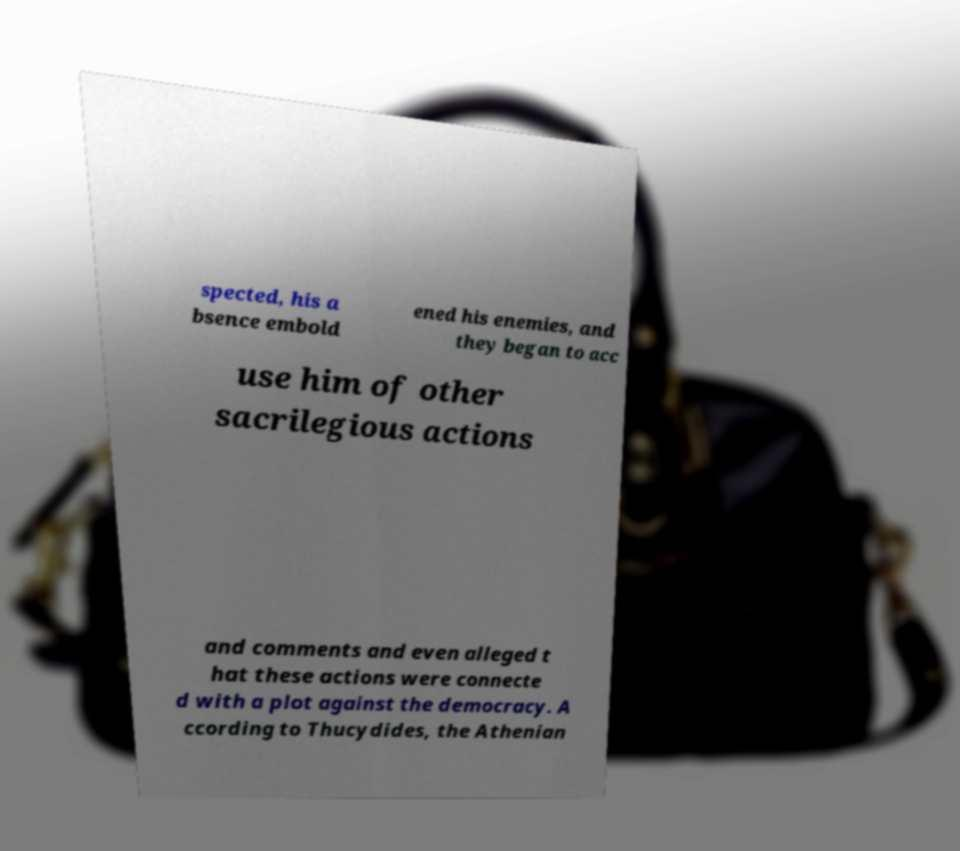Can you read and provide the text displayed in the image?This photo seems to have some interesting text. Can you extract and type it out for me? spected, his a bsence embold ened his enemies, and they began to acc use him of other sacrilegious actions and comments and even alleged t hat these actions were connecte d with a plot against the democracy. A ccording to Thucydides, the Athenian 